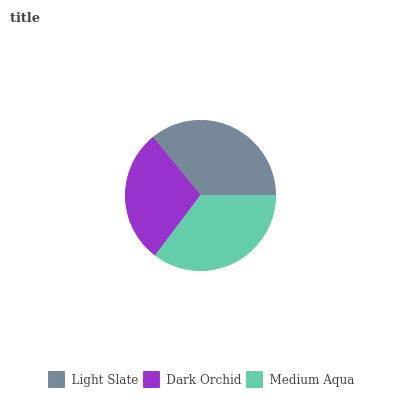Is Dark Orchid the minimum?
Answer yes or no. Yes. Is Light Slate the maximum?
Answer yes or no. Yes. Is Medium Aqua the minimum?
Answer yes or no. No. Is Medium Aqua the maximum?
Answer yes or no. No. Is Medium Aqua greater than Dark Orchid?
Answer yes or no. Yes. Is Dark Orchid less than Medium Aqua?
Answer yes or no. Yes. Is Dark Orchid greater than Medium Aqua?
Answer yes or no. No. Is Medium Aqua less than Dark Orchid?
Answer yes or no. No. Is Medium Aqua the high median?
Answer yes or no. Yes. Is Medium Aqua the low median?
Answer yes or no. Yes. Is Dark Orchid the high median?
Answer yes or no. No. Is Light Slate the low median?
Answer yes or no. No. 